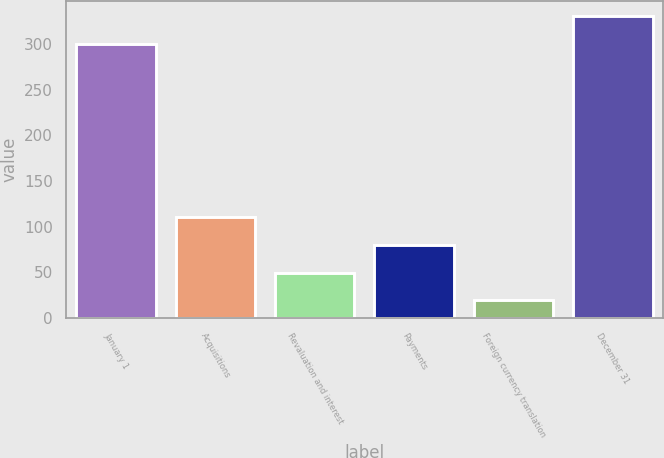Convert chart. <chart><loc_0><loc_0><loc_500><loc_500><bar_chart><fcel>January 1<fcel>Acquisitions<fcel>Revaluation and interest<fcel>Payments<fcel>Foreign currency translation<fcel>December 31<nl><fcel>300.7<fcel>110.18<fcel>49.66<fcel>79.92<fcel>19.4<fcel>330.96<nl></chart> 